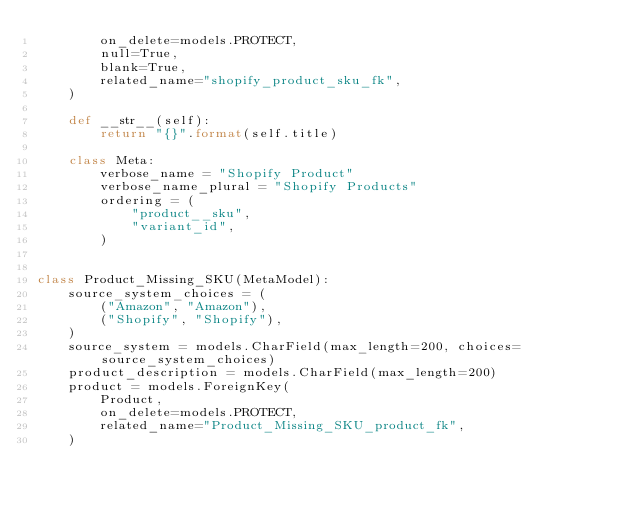<code> <loc_0><loc_0><loc_500><loc_500><_Python_>        on_delete=models.PROTECT,
        null=True,
        blank=True,
        related_name="shopify_product_sku_fk",
    )

    def __str__(self):
        return "{}".format(self.title)

    class Meta:
        verbose_name = "Shopify Product"
        verbose_name_plural = "Shopify Products"
        ordering = (
            "product__sku",
            "variant_id",
        )


class Product_Missing_SKU(MetaModel):
    source_system_choices = (
        ("Amazon", "Amazon"),
        ("Shopify", "Shopify"),
    )
    source_system = models.CharField(max_length=200, choices=source_system_choices)
    product_description = models.CharField(max_length=200)
    product = models.ForeignKey(
        Product,
        on_delete=models.PROTECT,
        related_name="Product_Missing_SKU_product_fk",
    )
</code> 